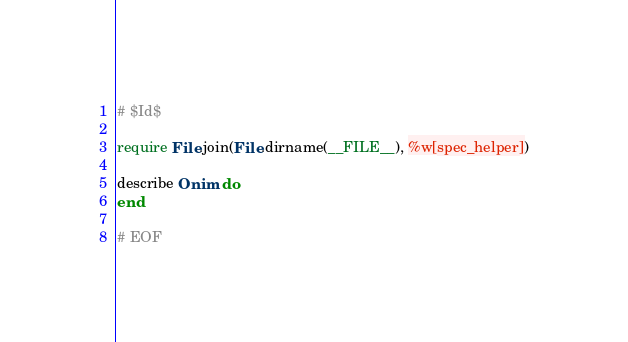Convert code to text. <code><loc_0><loc_0><loc_500><loc_500><_Ruby_># $Id$

require File.join(File.dirname(__FILE__), %w[spec_helper])

describe Onim do
end

# EOF
</code> 